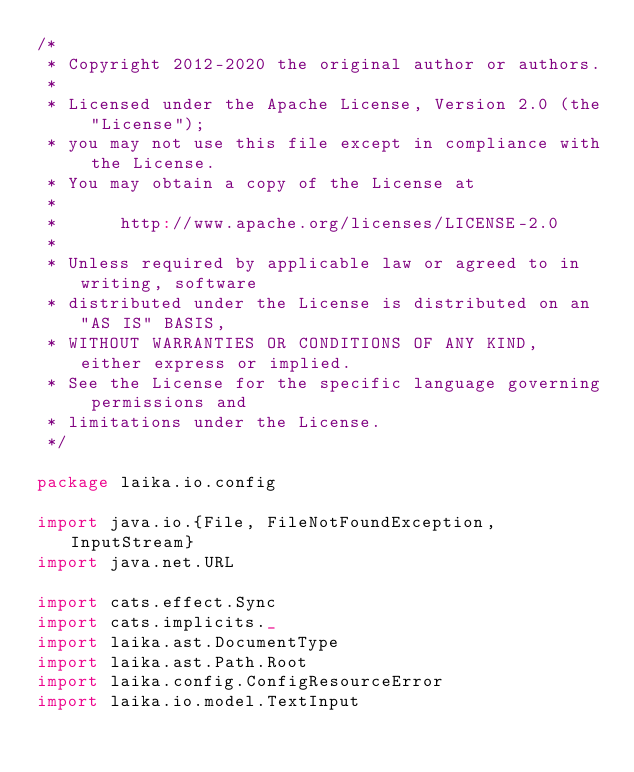<code> <loc_0><loc_0><loc_500><loc_500><_Scala_>/*
 * Copyright 2012-2020 the original author or authors.
 *
 * Licensed under the Apache License, Version 2.0 (the "License");
 * you may not use this file except in compliance with the License.
 * You may obtain a copy of the License at
 *
 *      http://www.apache.org/licenses/LICENSE-2.0
 *
 * Unless required by applicable law or agreed to in writing, software
 * distributed under the License is distributed on an "AS IS" BASIS,
 * WITHOUT WARRANTIES OR CONDITIONS OF ANY KIND, either express or implied.
 * See the License for the specific language governing permissions and
 * limitations under the License.
 */

package laika.io.config

import java.io.{File, FileNotFoundException, InputStream}
import java.net.URL

import cats.effect.Sync
import cats.implicits._
import laika.ast.DocumentType
import laika.ast.Path.Root
import laika.config.ConfigResourceError
import laika.io.model.TextInput</code> 